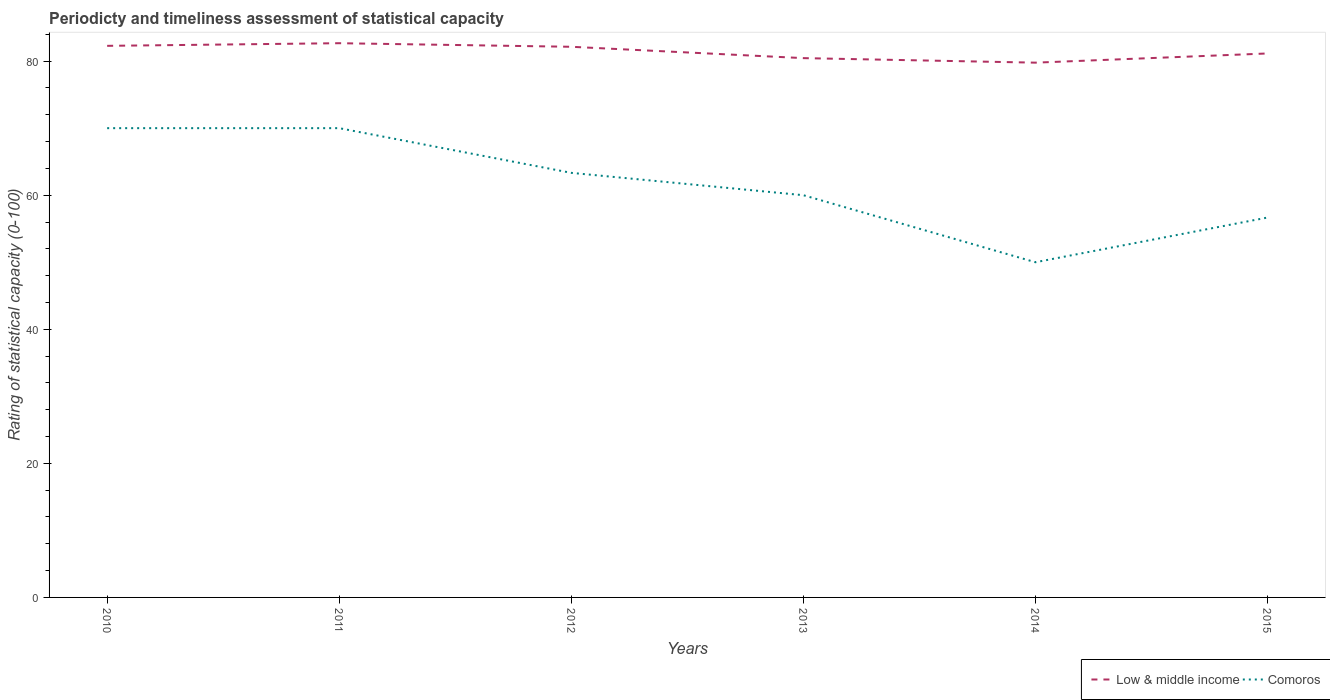How many different coloured lines are there?
Provide a succinct answer. 2. Is the number of lines equal to the number of legend labels?
Give a very brief answer. Yes. Across all years, what is the maximum rating of statistical capacity in Comoros?
Keep it short and to the point. 50. In which year was the rating of statistical capacity in Comoros maximum?
Your response must be concise. 2014. What is the total rating of statistical capacity in Low & middle income in the graph?
Provide a short and direct response. 1.69. What is the difference between the highest and the second highest rating of statistical capacity in Comoros?
Make the answer very short. 20. How many lines are there?
Provide a short and direct response. 2. How many years are there in the graph?
Make the answer very short. 6. What is the difference between two consecutive major ticks on the Y-axis?
Your answer should be compact. 20. Does the graph contain any zero values?
Your answer should be very brief. No. Where does the legend appear in the graph?
Ensure brevity in your answer.  Bottom right. How many legend labels are there?
Offer a very short reply. 2. How are the legend labels stacked?
Your answer should be compact. Horizontal. What is the title of the graph?
Ensure brevity in your answer.  Periodicty and timeliness assessment of statistical capacity. What is the label or title of the Y-axis?
Offer a very short reply. Rating of statistical capacity (0-100). What is the Rating of statistical capacity (0-100) in Low & middle income in 2010?
Provide a succinct answer. 82.28. What is the Rating of statistical capacity (0-100) in Low & middle income in 2011?
Provide a succinct answer. 82.67. What is the Rating of statistical capacity (0-100) in Low & middle income in 2012?
Offer a very short reply. 82.14. What is the Rating of statistical capacity (0-100) in Comoros in 2012?
Make the answer very short. 63.33. What is the Rating of statistical capacity (0-100) in Low & middle income in 2013?
Your response must be concise. 80.45. What is the Rating of statistical capacity (0-100) of Low & middle income in 2014?
Offer a very short reply. 79.77. What is the Rating of statistical capacity (0-100) in Comoros in 2014?
Keep it short and to the point. 50. What is the Rating of statistical capacity (0-100) of Low & middle income in 2015?
Ensure brevity in your answer.  81.14. What is the Rating of statistical capacity (0-100) of Comoros in 2015?
Provide a short and direct response. 56.67. Across all years, what is the maximum Rating of statistical capacity (0-100) in Low & middle income?
Your answer should be compact. 82.67. Across all years, what is the minimum Rating of statistical capacity (0-100) in Low & middle income?
Make the answer very short. 79.77. Across all years, what is the minimum Rating of statistical capacity (0-100) of Comoros?
Your answer should be very brief. 50. What is the total Rating of statistical capacity (0-100) in Low & middle income in the graph?
Make the answer very short. 488.45. What is the total Rating of statistical capacity (0-100) of Comoros in the graph?
Provide a short and direct response. 370. What is the difference between the Rating of statistical capacity (0-100) in Low & middle income in 2010 and that in 2011?
Your answer should be compact. -0.39. What is the difference between the Rating of statistical capacity (0-100) in Comoros in 2010 and that in 2011?
Keep it short and to the point. 0. What is the difference between the Rating of statistical capacity (0-100) of Low & middle income in 2010 and that in 2012?
Your answer should be compact. 0.14. What is the difference between the Rating of statistical capacity (0-100) in Comoros in 2010 and that in 2012?
Provide a short and direct response. 6.67. What is the difference between the Rating of statistical capacity (0-100) of Low & middle income in 2010 and that in 2013?
Make the answer very short. 1.83. What is the difference between the Rating of statistical capacity (0-100) of Comoros in 2010 and that in 2013?
Your answer should be very brief. 10. What is the difference between the Rating of statistical capacity (0-100) in Low & middle income in 2010 and that in 2014?
Provide a short and direct response. 2.51. What is the difference between the Rating of statistical capacity (0-100) of Low & middle income in 2010 and that in 2015?
Your answer should be very brief. 1.14. What is the difference between the Rating of statistical capacity (0-100) of Comoros in 2010 and that in 2015?
Give a very brief answer. 13.33. What is the difference between the Rating of statistical capacity (0-100) in Low & middle income in 2011 and that in 2012?
Your answer should be compact. 0.53. What is the difference between the Rating of statistical capacity (0-100) of Low & middle income in 2011 and that in 2013?
Provide a short and direct response. 2.23. What is the difference between the Rating of statistical capacity (0-100) of Low & middle income in 2011 and that in 2014?
Make the answer very short. 2.9. What is the difference between the Rating of statistical capacity (0-100) of Low & middle income in 2011 and that in 2015?
Your answer should be very brief. 1.53. What is the difference between the Rating of statistical capacity (0-100) of Comoros in 2011 and that in 2015?
Provide a short and direct response. 13.33. What is the difference between the Rating of statistical capacity (0-100) in Low & middle income in 2012 and that in 2013?
Provide a short and direct response. 1.69. What is the difference between the Rating of statistical capacity (0-100) of Comoros in 2012 and that in 2013?
Keep it short and to the point. 3.33. What is the difference between the Rating of statistical capacity (0-100) of Low & middle income in 2012 and that in 2014?
Make the answer very short. 2.37. What is the difference between the Rating of statistical capacity (0-100) in Comoros in 2012 and that in 2014?
Provide a short and direct response. 13.33. What is the difference between the Rating of statistical capacity (0-100) of Comoros in 2012 and that in 2015?
Keep it short and to the point. 6.67. What is the difference between the Rating of statistical capacity (0-100) in Low & middle income in 2013 and that in 2014?
Keep it short and to the point. 0.68. What is the difference between the Rating of statistical capacity (0-100) in Comoros in 2013 and that in 2014?
Make the answer very short. 10. What is the difference between the Rating of statistical capacity (0-100) of Low & middle income in 2013 and that in 2015?
Provide a short and direct response. -0.69. What is the difference between the Rating of statistical capacity (0-100) in Comoros in 2013 and that in 2015?
Provide a short and direct response. 3.33. What is the difference between the Rating of statistical capacity (0-100) in Low & middle income in 2014 and that in 2015?
Offer a terse response. -1.37. What is the difference between the Rating of statistical capacity (0-100) of Comoros in 2014 and that in 2015?
Give a very brief answer. -6.67. What is the difference between the Rating of statistical capacity (0-100) of Low & middle income in 2010 and the Rating of statistical capacity (0-100) of Comoros in 2011?
Provide a short and direct response. 12.28. What is the difference between the Rating of statistical capacity (0-100) in Low & middle income in 2010 and the Rating of statistical capacity (0-100) in Comoros in 2012?
Your answer should be compact. 18.95. What is the difference between the Rating of statistical capacity (0-100) of Low & middle income in 2010 and the Rating of statistical capacity (0-100) of Comoros in 2013?
Offer a very short reply. 22.28. What is the difference between the Rating of statistical capacity (0-100) in Low & middle income in 2010 and the Rating of statistical capacity (0-100) in Comoros in 2014?
Provide a short and direct response. 32.28. What is the difference between the Rating of statistical capacity (0-100) in Low & middle income in 2010 and the Rating of statistical capacity (0-100) in Comoros in 2015?
Keep it short and to the point. 25.61. What is the difference between the Rating of statistical capacity (0-100) in Low & middle income in 2011 and the Rating of statistical capacity (0-100) in Comoros in 2012?
Give a very brief answer. 19.34. What is the difference between the Rating of statistical capacity (0-100) in Low & middle income in 2011 and the Rating of statistical capacity (0-100) in Comoros in 2013?
Keep it short and to the point. 22.67. What is the difference between the Rating of statistical capacity (0-100) of Low & middle income in 2011 and the Rating of statistical capacity (0-100) of Comoros in 2014?
Offer a terse response. 32.67. What is the difference between the Rating of statistical capacity (0-100) in Low & middle income in 2011 and the Rating of statistical capacity (0-100) in Comoros in 2015?
Offer a terse response. 26.01. What is the difference between the Rating of statistical capacity (0-100) of Low & middle income in 2012 and the Rating of statistical capacity (0-100) of Comoros in 2013?
Your answer should be compact. 22.14. What is the difference between the Rating of statistical capacity (0-100) of Low & middle income in 2012 and the Rating of statistical capacity (0-100) of Comoros in 2014?
Your answer should be compact. 32.14. What is the difference between the Rating of statistical capacity (0-100) of Low & middle income in 2012 and the Rating of statistical capacity (0-100) of Comoros in 2015?
Provide a succinct answer. 25.47. What is the difference between the Rating of statistical capacity (0-100) of Low & middle income in 2013 and the Rating of statistical capacity (0-100) of Comoros in 2014?
Provide a short and direct response. 30.45. What is the difference between the Rating of statistical capacity (0-100) of Low & middle income in 2013 and the Rating of statistical capacity (0-100) of Comoros in 2015?
Your answer should be compact. 23.78. What is the difference between the Rating of statistical capacity (0-100) of Low & middle income in 2014 and the Rating of statistical capacity (0-100) of Comoros in 2015?
Provide a short and direct response. 23.11. What is the average Rating of statistical capacity (0-100) of Low & middle income per year?
Your answer should be compact. 81.41. What is the average Rating of statistical capacity (0-100) of Comoros per year?
Offer a very short reply. 61.67. In the year 2010, what is the difference between the Rating of statistical capacity (0-100) in Low & middle income and Rating of statistical capacity (0-100) in Comoros?
Ensure brevity in your answer.  12.28. In the year 2011, what is the difference between the Rating of statistical capacity (0-100) of Low & middle income and Rating of statistical capacity (0-100) of Comoros?
Your response must be concise. 12.67. In the year 2012, what is the difference between the Rating of statistical capacity (0-100) in Low & middle income and Rating of statistical capacity (0-100) in Comoros?
Keep it short and to the point. 18.8. In the year 2013, what is the difference between the Rating of statistical capacity (0-100) in Low & middle income and Rating of statistical capacity (0-100) in Comoros?
Your answer should be compact. 20.45. In the year 2014, what is the difference between the Rating of statistical capacity (0-100) of Low & middle income and Rating of statistical capacity (0-100) of Comoros?
Keep it short and to the point. 29.77. In the year 2015, what is the difference between the Rating of statistical capacity (0-100) of Low & middle income and Rating of statistical capacity (0-100) of Comoros?
Ensure brevity in your answer.  24.48. What is the ratio of the Rating of statistical capacity (0-100) in Low & middle income in 2010 to that in 2011?
Your answer should be compact. 1. What is the ratio of the Rating of statistical capacity (0-100) in Comoros in 2010 to that in 2011?
Ensure brevity in your answer.  1. What is the ratio of the Rating of statistical capacity (0-100) of Low & middle income in 2010 to that in 2012?
Provide a succinct answer. 1. What is the ratio of the Rating of statistical capacity (0-100) of Comoros in 2010 to that in 2012?
Your answer should be very brief. 1.11. What is the ratio of the Rating of statistical capacity (0-100) of Low & middle income in 2010 to that in 2013?
Make the answer very short. 1.02. What is the ratio of the Rating of statistical capacity (0-100) of Low & middle income in 2010 to that in 2014?
Provide a succinct answer. 1.03. What is the ratio of the Rating of statistical capacity (0-100) of Comoros in 2010 to that in 2015?
Ensure brevity in your answer.  1.24. What is the ratio of the Rating of statistical capacity (0-100) of Low & middle income in 2011 to that in 2012?
Ensure brevity in your answer.  1.01. What is the ratio of the Rating of statistical capacity (0-100) of Comoros in 2011 to that in 2012?
Your answer should be very brief. 1.11. What is the ratio of the Rating of statistical capacity (0-100) in Low & middle income in 2011 to that in 2013?
Your answer should be very brief. 1.03. What is the ratio of the Rating of statistical capacity (0-100) in Comoros in 2011 to that in 2013?
Your response must be concise. 1.17. What is the ratio of the Rating of statistical capacity (0-100) of Low & middle income in 2011 to that in 2014?
Make the answer very short. 1.04. What is the ratio of the Rating of statistical capacity (0-100) of Comoros in 2011 to that in 2014?
Keep it short and to the point. 1.4. What is the ratio of the Rating of statistical capacity (0-100) in Low & middle income in 2011 to that in 2015?
Your answer should be compact. 1.02. What is the ratio of the Rating of statistical capacity (0-100) of Comoros in 2011 to that in 2015?
Provide a short and direct response. 1.24. What is the ratio of the Rating of statistical capacity (0-100) in Comoros in 2012 to that in 2013?
Your response must be concise. 1.06. What is the ratio of the Rating of statistical capacity (0-100) in Low & middle income in 2012 to that in 2014?
Offer a very short reply. 1.03. What is the ratio of the Rating of statistical capacity (0-100) in Comoros in 2012 to that in 2014?
Provide a short and direct response. 1.27. What is the ratio of the Rating of statistical capacity (0-100) of Low & middle income in 2012 to that in 2015?
Your answer should be compact. 1.01. What is the ratio of the Rating of statistical capacity (0-100) in Comoros in 2012 to that in 2015?
Offer a terse response. 1.12. What is the ratio of the Rating of statistical capacity (0-100) in Low & middle income in 2013 to that in 2014?
Keep it short and to the point. 1.01. What is the ratio of the Rating of statistical capacity (0-100) in Low & middle income in 2013 to that in 2015?
Your response must be concise. 0.99. What is the ratio of the Rating of statistical capacity (0-100) in Comoros in 2013 to that in 2015?
Provide a short and direct response. 1.06. What is the ratio of the Rating of statistical capacity (0-100) in Low & middle income in 2014 to that in 2015?
Make the answer very short. 0.98. What is the ratio of the Rating of statistical capacity (0-100) of Comoros in 2014 to that in 2015?
Ensure brevity in your answer.  0.88. What is the difference between the highest and the second highest Rating of statistical capacity (0-100) in Low & middle income?
Ensure brevity in your answer.  0.39. What is the difference between the highest and the second highest Rating of statistical capacity (0-100) of Comoros?
Your answer should be very brief. 0. What is the difference between the highest and the lowest Rating of statistical capacity (0-100) in Low & middle income?
Make the answer very short. 2.9. 